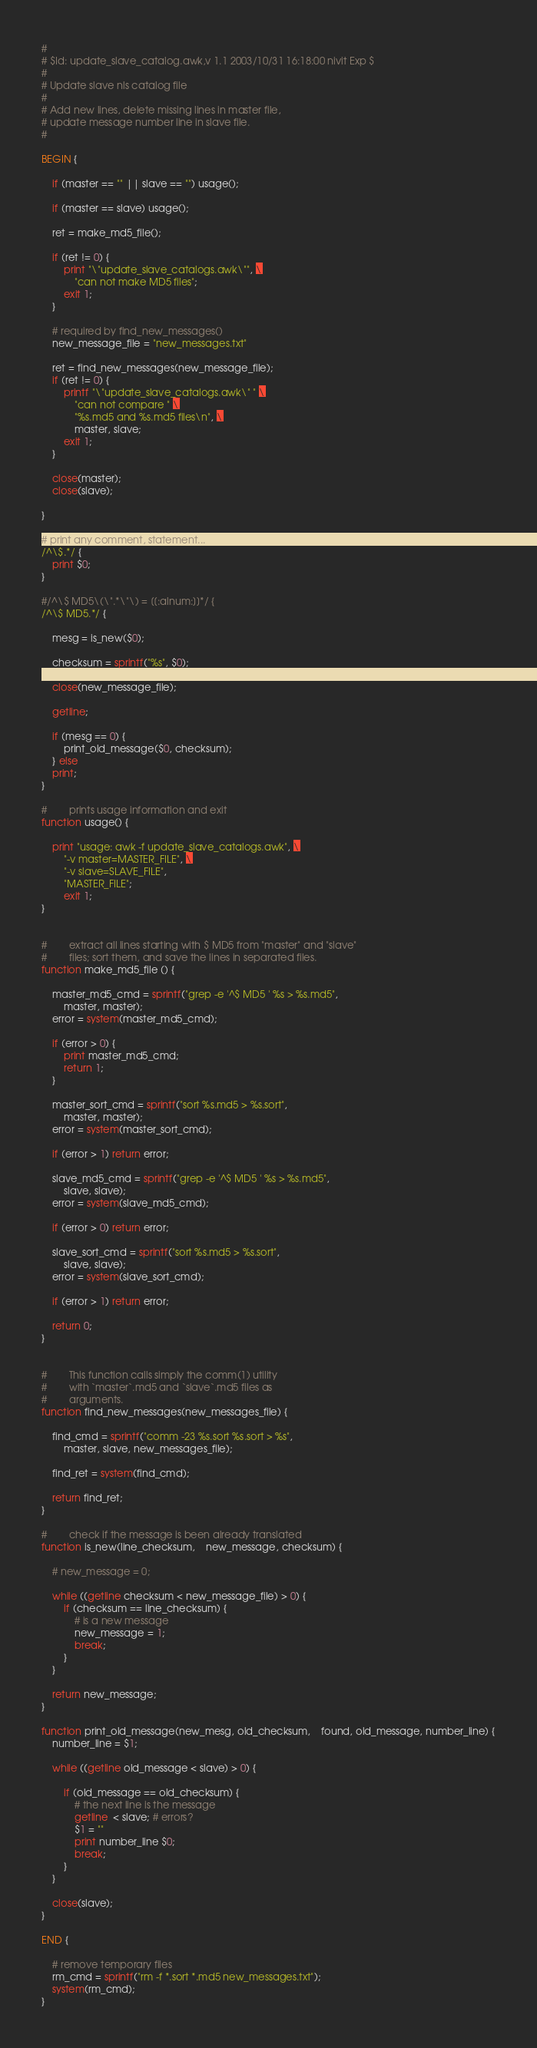Convert code to text. <code><loc_0><loc_0><loc_500><loc_500><_Awk_>#
# $Id: update_slave_catalog.awk,v 1.1 2003/10/31 16:18:00 nivit Exp $
#
# Update slave nls catalog file
#
# Add new lines, delete missing lines in master file,
# update message number line in slave file.
#

BEGIN {

	if (master == "" || slave == "") usage();

	if (master == slave) usage();

	ret = make_md5_file();

	if (ret != 0) {
		print "\"update_slave_catalogs.awk\"", \
			"can not make MD5 files";
		exit 1;
	}

	# required by find_new_messages()
	new_message_file = "new_messages.txt"

	ret = find_new_messages(new_message_file);
	if (ret != 0) {
		printf "\"update_slave_catalogs.awk\" " \
			"can not compare " \
			"%s.md5 and %s.md5 files\n", \
			master, slave;
		exit 1;
	}

	close(master);
	close(slave);

}

# print any comment, statement...
/^\$.*/ {
	print $0;
}

#/^\$ MD5\(\".*\"\) = [[:alnum:]]*/ {
/^\$ MD5.*/ {

	mesg = is_new($0);

	checksum = sprintf("%s", $0);

	close(new_message_file);

	getline;

	if (mesg == 0) {
		print_old_message($0, checksum);
	} else 
	print;
}

#        prints usage information and exit
function usage() {

	print "usage: awk -f update_slave_catalogs.awk", \
		"-v master=MASTER_FILE", \
		"-v slave=SLAVE_FILE",
		"MASTER_FILE";
		exit 1;
}


#        extract all lines starting with $ MD5 from "master" and "slave"
#        files; sort them, and save the lines in separated files.
function make_md5_file () {

	master_md5_cmd = sprintf("grep -e '^$ MD5 ' %s > %s.md5",
	    master, master);
	error = system(master_md5_cmd);

	if (error > 0) {
		print master_md5_cmd;
		return 1;
	}

	master_sort_cmd = sprintf("sort %s.md5 > %s.sort",
	    master, master);
	error = system(master_sort_cmd);

	if (error > 1) return error;

	slave_md5_cmd = sprintf("grep -e '^$ MD5 ' %s > %s.md5",
	    slave, slave);
	error = system(slave_md5_cmd);

	if (error > 0) return error;

	slave_sort_cmd = sprintf("sort %s.md5 > %s.sort",
	    slave, slave);
	error = system(slave_sort_cmd);

	if (error > 1) return error;

	return 0;
}


#        This function calls simply the comm(1) utility
#        with `master`.md5 and `slave`.md5 files as
#        arguments.
function find_new_messages(new_messages_file) {

	find_cmd = sprintf("comm -23 %s.sort %s.sort > %s",
	    master, slave, new_messages_file);

	find_ret = system(find_cmd);

	return find_ret;
}

#        check if the message is been already translated
function is_new(line_checksum,    new_message, checksum) {

	# new_message = 0;

	while ((getline checksum < new_message_file) > 0) {
		if (checksum == line_checksum) {
			# is a new message
			new_message = 1;
			break;
		}
	}

	return new_message;
}

function print_old_message(new_mesg, old_checksum,    found, old_message, number_line) {
	number_line = $1;

	while ((getline old_message < slave) > 0) {

		if (old_message == old_checksum) {
			# the next line is the message
			getline  < slave; # errors?
			$1 = ""
			print number_line $0;
			break;
		}
	}

	close(slave);
}

END {

	# remove temporary files
	rm_cmd = sprintf("rm -f *.sort *.md5 new_messages.txt");
	system(rm_cmd);
}
</code> 